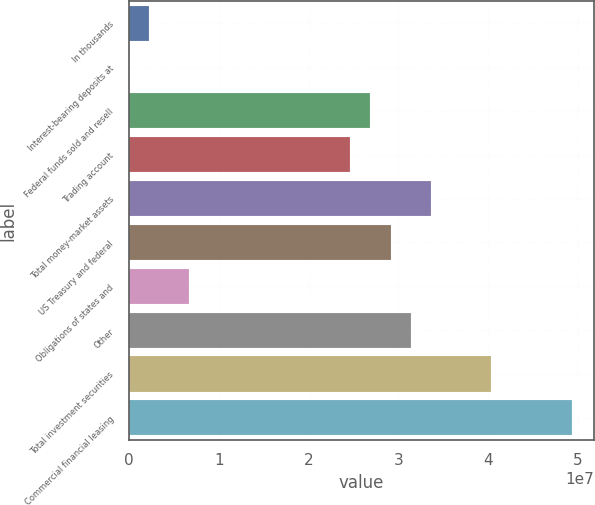<chart> <loc_0><loc_0><loc_500><loc_500><bar_chart><fcel>In thousands<fcel>Interest-bearing deposits at<fcel>Federal funds sold and resell<fcel>Trading account<fcel>Total money-market assets<fcel>US Treasury and federal<fcel>Obligations of states and<fcel>Other<fcel>Total investment securities<fcel>Commercial financial leasing<nl><fcel>2.24189e+06<fcel>1092<fcel>2.68907e+07<fcel>2.46499e+07<fcel>3.36131e+07<fcel>2.91315e+07<fcel>6.7235e+06<fcel>3.13723e+07<fcel>4.03355e+07<fcel>4.92987e+07<nl></chart> 